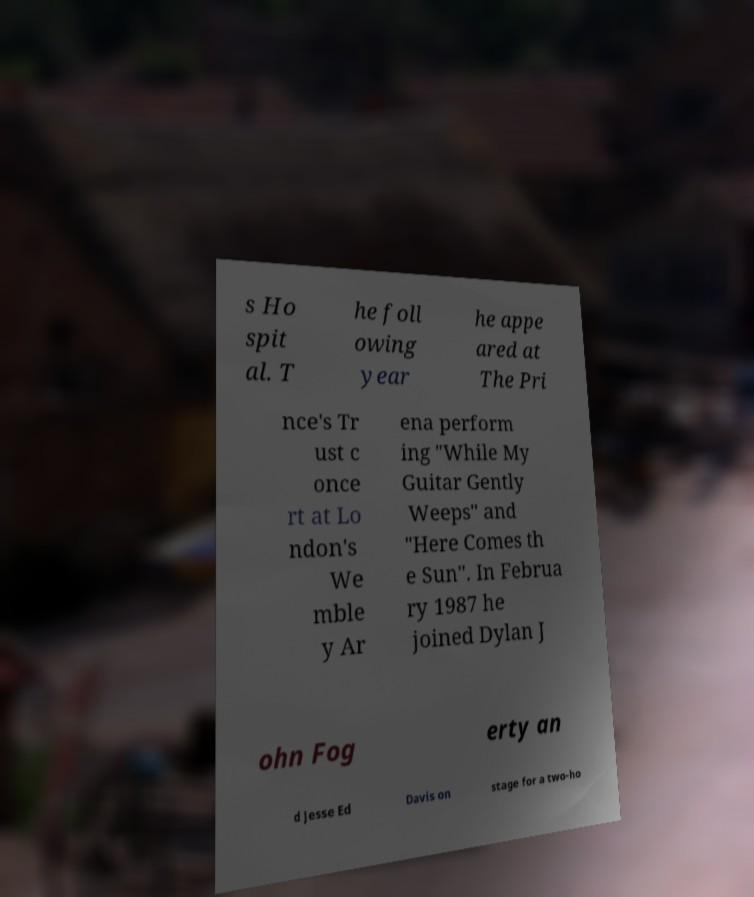Can you accurately transcribe the text from the provided image for me? s Ho spit al. T he foll owing year he appe ared at The Pri nce's Tr ust c once rt at Lo ndon's We mble y Ar ena perform ing "While My Guitar Gently Weeps" and "Here Comes th e Sun". In Februa ry 1987 he joined Dylan J ohn Fog erty an d Jesse Ed Davis on stage for a two-ho 